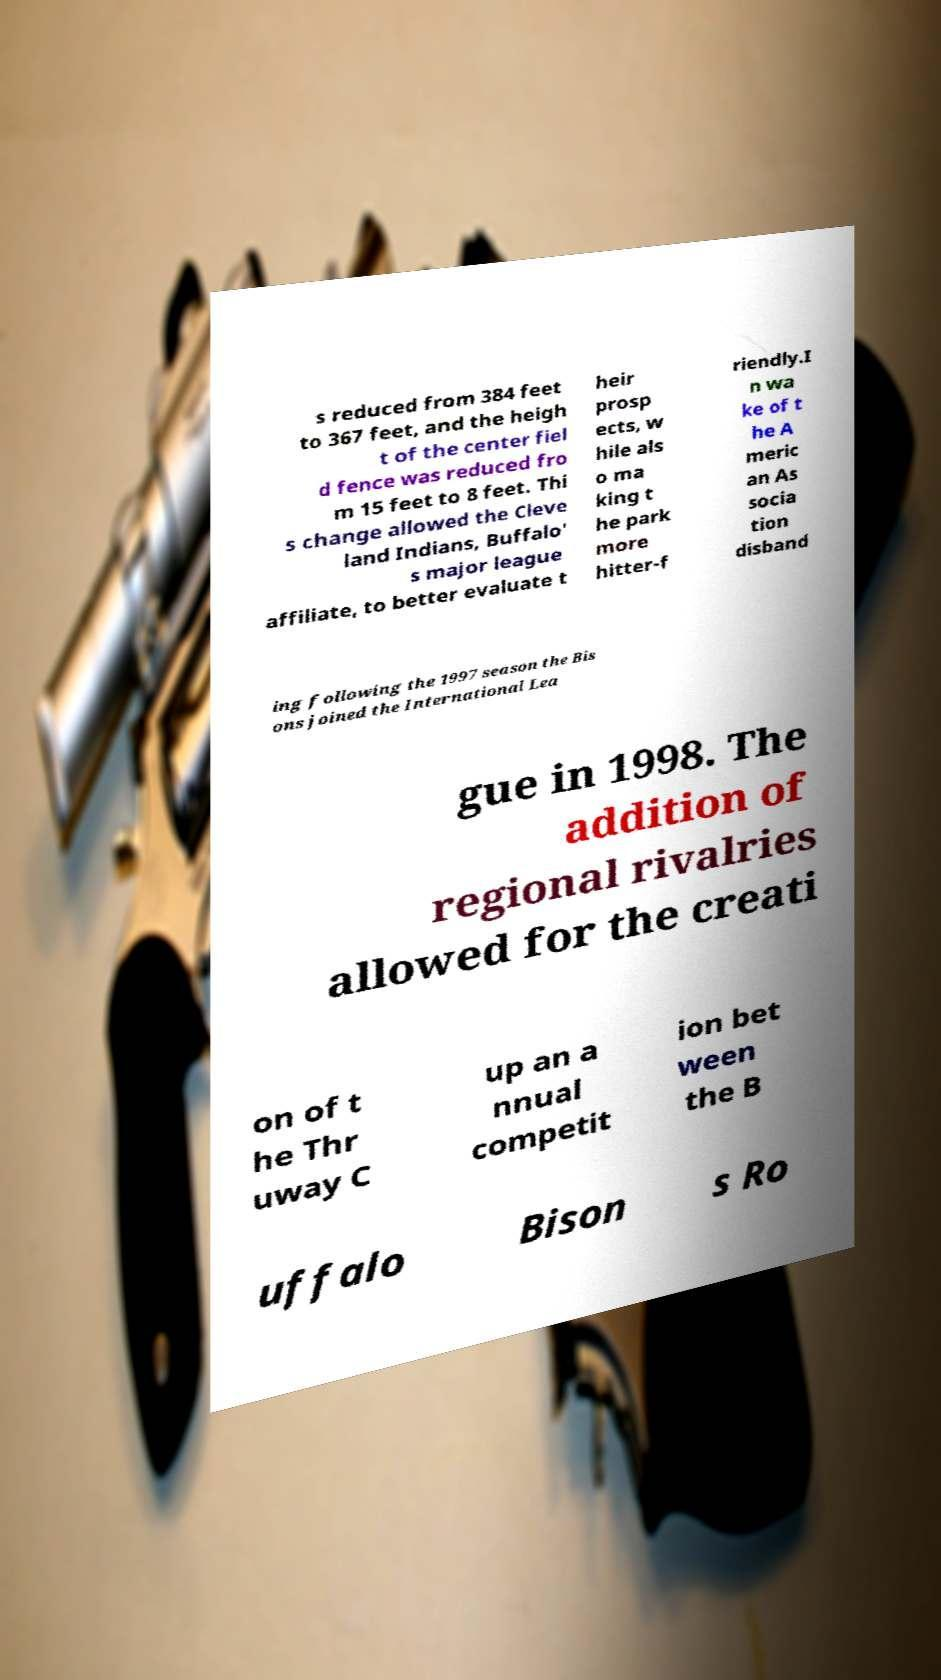Could you assist in decoding the text presented in this image and type it out clearly? s reduced from 384 feet to 367 feet, and the heigh t of the center fiel d fence was reduced fro m 15 feet to 8 feet. Thi s change allowed the Cleve land Indians, Buffalo' s major league affiliate, to better evaluate t heir prosp ects, w hile als o ma king t he park more hitter-f riendly.I n wa ke of t he A meric an As socia tion disband ing following the 1997 season the Bis ons joined the International Lea gue in 1998. The addition of regional rivalries allowed for the creati on of t he Thr uway C up an a nnual competit ion bet ween the B uffalo Bison s Ro 